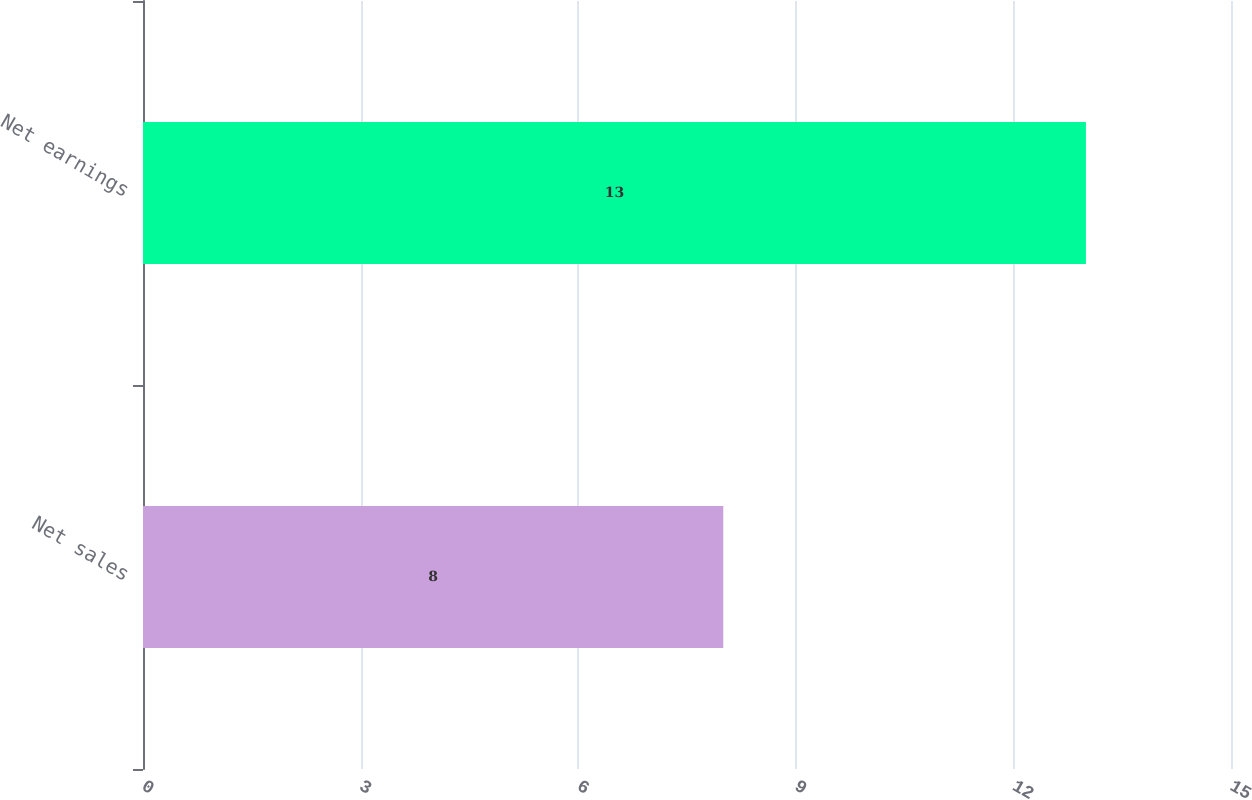Convert chart to OTSL. <chart><loc_0><loc_0><loc_500><loc_500><bar_chart><fcel>Net sales<fcel>Net earnings<nl><fcel>8<fcel>13<nl></chart> 